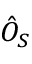<formula> <loc_0><loc_0><loc_500><loc_500>\hat { O } _ { S }</formula> 